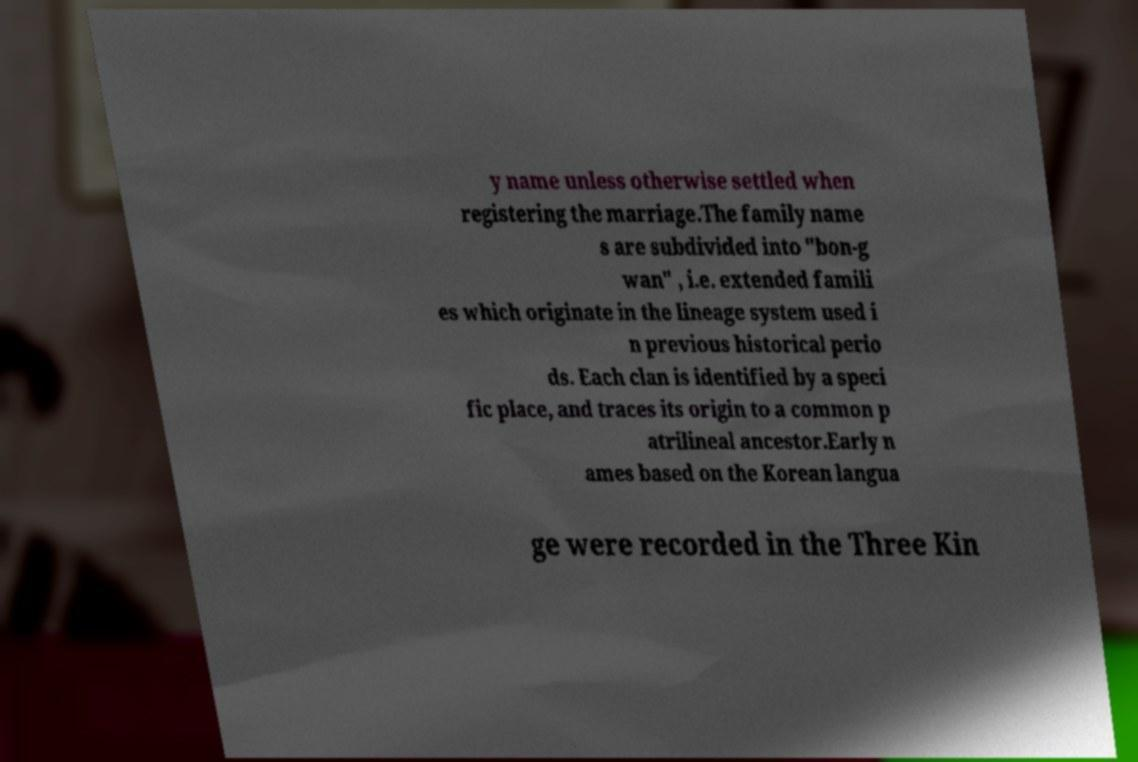Please read and relay the text visible in this image. What does it say? y name unless otherwise settled when registering the marriage.The family name s are subdivided into "bon-g wan" , i.e. extended famili es which originate in the lineage system used i n previous historical perio ds. Each clan is identified by a speci fic place, and traces its origin to a common p atrilineal ancestor.Early n ames based on the Korean langua ge were recorded in the Three Kin 